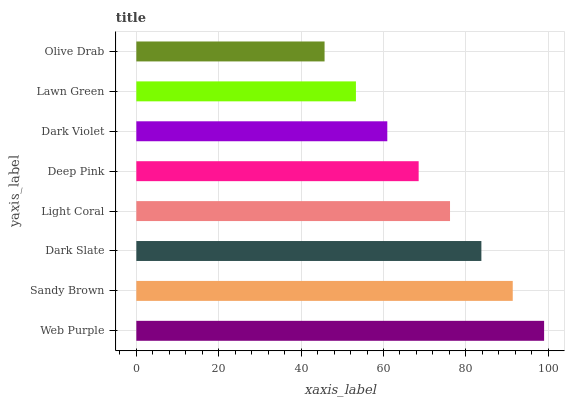Is Olive Drab the minimum?
Answer yes or no. Yes. Is Web Purple the maximum?
Answer yes or no. Yes. Is Sandy Brown the minimum?
Answer yes or no. No. Is Sandy Brown the maximum?
Answer yes or no. No. Is Web Purple greater than Sandy Brown?
Answer yes or no. Yes. Is Sandy Brown less than Web Purple?
Answer yes or no. Yes. Is Sandy Brown greater than Web Purple?
Answer yes or no. No. Is Web Purple less than Sandy Brown?
Answer yes or no. No. Is Light Coral the high median?
Answer yes or no. Yes. Is Deep Pink the low median?
Answer yes or no. Yes. Is Dark Slate the high median?
Answer yes or no. No. Is Dark Violet the low median?
Answer yes or no. No. 